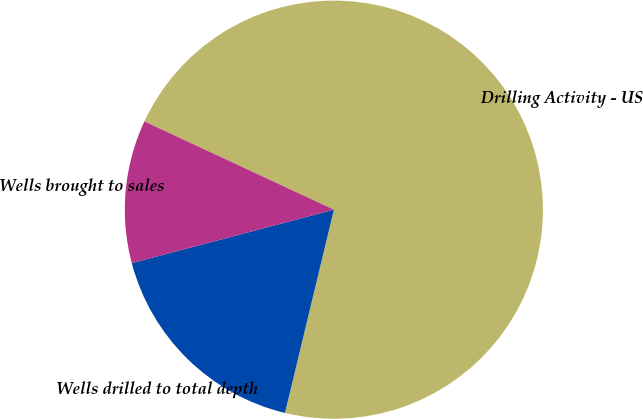Convert chart. <chart><loc_0><loc_0><loc_500><loc_500><pie_chart><fcel>Drilling Activity - US<fcel>Wells drilled to total depth<fcel>Wells brought to sales<nl><fcel>71.82%<fcel>17.13%<fcel>11.05%<nl></chart> 